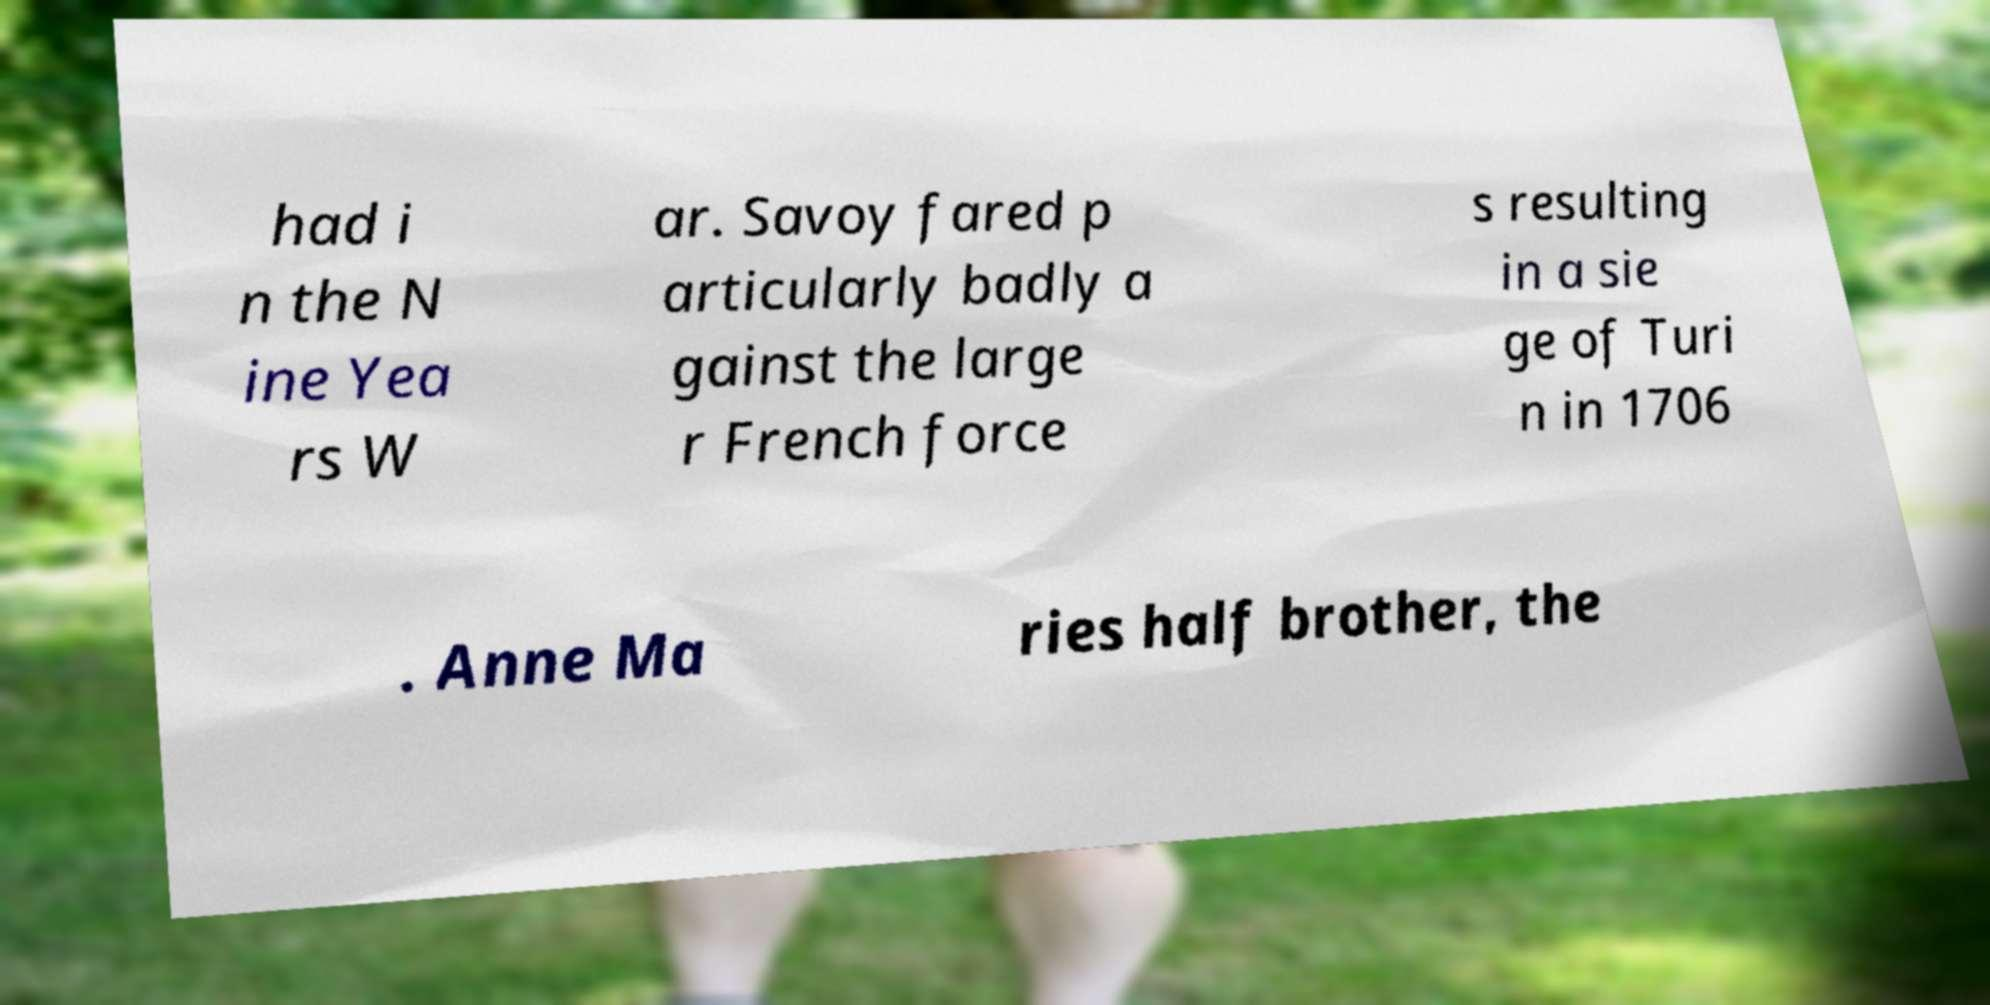What messages or text are displayed in this image? I need them in a readable, typed format. had i n the N ine Yea rs W ar. Savoy fared p articularly badly a gainst the large r French force s resulting in a sie ge of Turi n in 1706 . Anne Ma ries half brother, the 